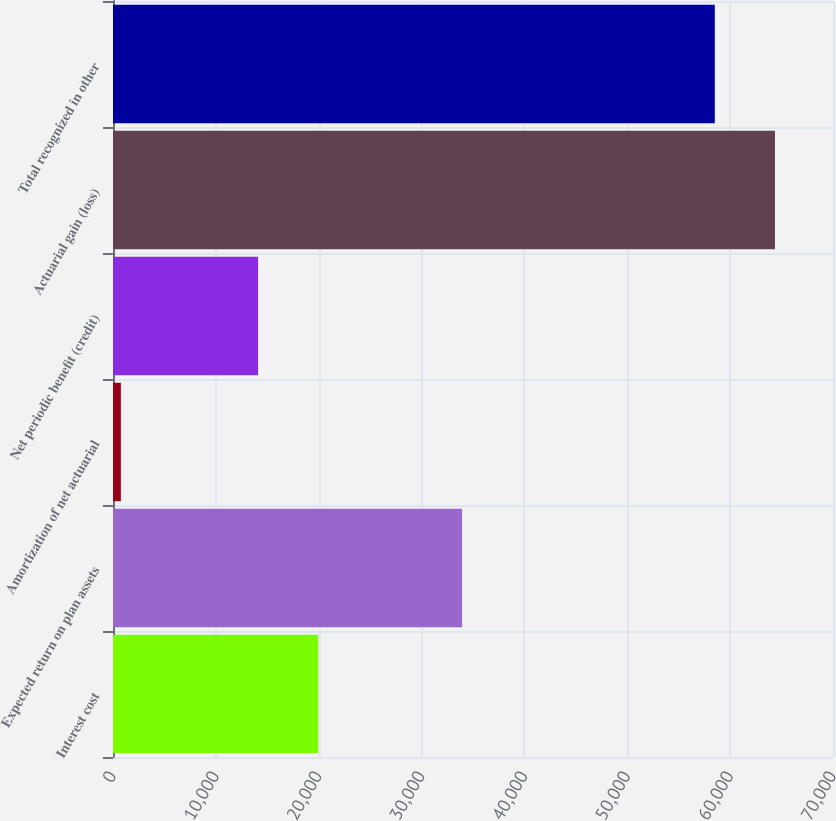Convert chart. <chart><loc_0><loc_0><loc_500><loc_500><bar_chart><fcel>Interest cost<fcel>Expected return on plan assets<fcel>Amortization of net actuarial<fcel>Net periodic benefit (credit)<fcel>Actuarial gain (loss)<fcel>Total recognized in other<nl><fcel>19956.9<fcel>33942<fcel>763<fcel>14106<fcel>64359.9<fcel>58509<nl></chart> 